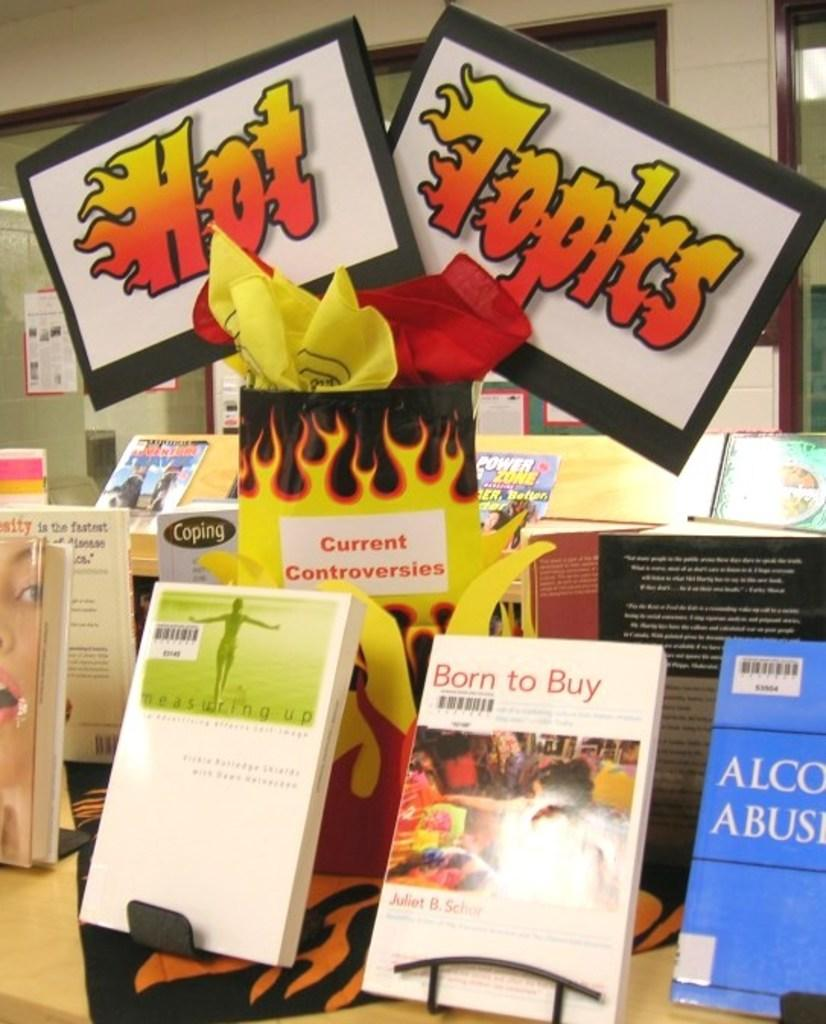<image>
Describe the image concisely. The words hot topics written in flames are above a selected group of books. 